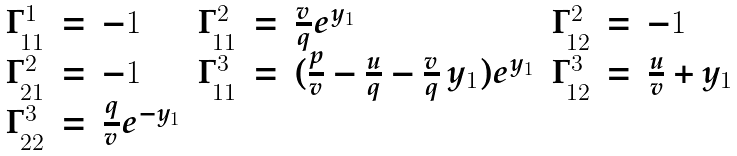Convert formula to latex. <formula><loc_0><loc_0><loc_500><loc_500>\begin{array} { r c l r c l r c l } \Gamma ^ { 1 } _ { 1 1 } & = & - 1 & \Gamma ^ { 2 } _ { 1 1 } & = & \frac { v } { q } e ^ { y _ { 1 } } & \Gamma ^ { 2 } _ { 1 2 } & = & - 1 \\ \Gamma ^ { 2 } _ { 2 1 } & = & - 1 & \Gamma ^ { 3 } _ { 1 1 } & = & ( \frac { p } { v } - \frac { u } { q } - \frac { v } { q } \, y _ { 1 } ) e ^ { y _ { 1 } } & \Gamma ^ { 3 } _ { 1 2 } & = & \frac { u } { v } + y _ { 1 } \\ \Gamma ^ { 3 } _ { 2 2 } & = & \frac { q } { v } e ^ { - y _ { 1 } } \\ \end{array}</formula> 